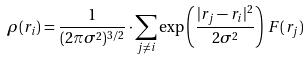Convert formula to latex. <formula><loc_0><loc_0><loc_500><loc_500>\rho ( { r } _ { i } ) = \frac { 1 } { ( 2 \pi \sigma ^ { 2 } ) ^ { 3 / 2 } } \cdot \sum _ { j \neq i } \exp \left ( \frac { | { r } _ { j } - { r _ { i } } | ^ { 2 } } { 2 \sigma ^ { 2 } } \right ) \, F ( r _ { j } )</formula> 